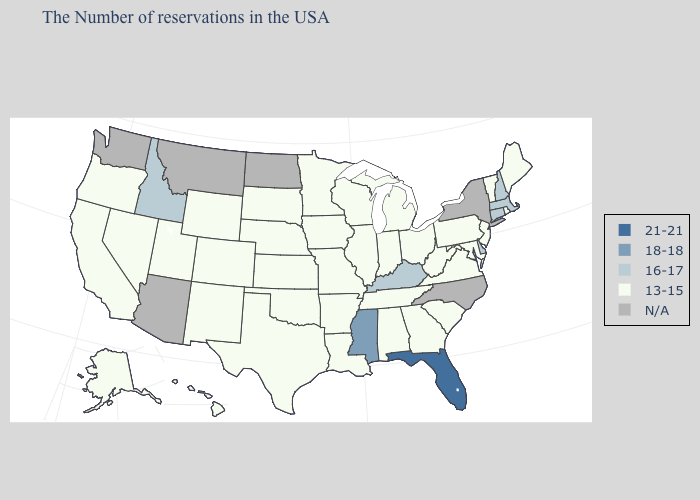Which states have the lowest value in the MidWest?
Write a very short answer. Ohio, Michigan, Indiana, Wisconsin, Illinois, Missouri, Minnesota, Iowa, Kansas, Nebraska, South Dakota. Which states have the lowest value in the USA?
Give a very brief answer. Maine, Rhode Island, Vermont, New Jersey, Maryland, Pennsylvania, Virginia, South Carolina, West Virginia, Ohio, Georgia, Michigan, Indiana, Alabama, Tennessee, Wisconsin, Illinois, Louisiana, Missouri, Arkansas, Minnesota, Iowa, Kansas, Nebraska, Oklahoma, Texas, South Dakota, Wyoming, Colorado, New Mexico, Utah, Nevada, California, Oregon, Alaska, Hawaii. Which states have the highest value in the USA?
Keep it brief. Florida. Among the states that border Missouri , does Iowa have the highest value?
Quick response, please. No. Name the states that have a value in the range N/A?
Concise answer only. New York, North Carolina, North Dakota, Montana, Arizona, Washington. Does the first symbol in the legend represent the smallest category?
Quick response, please. No. Does Massachusetts have the highest value in the Northeast?
Quick response, please. Yes. Does the map have missing data?
Keep it brief. Yes. Which states have the lowest value in the MidWest?
Give a very brief answer. Ohio, Michigan, Indiana, Wisconsin, Illinois, Missouri, Minnesota, Iowa, Kansas, Nebraska, South Dakota. How many symbols are there in the legend?
Be succinct. 5. What is the highest value in the Northeast ?
Be succinct. 16-17. Name the states that have a value in the range 13-15?
Write a very short answer. Maine, Rhode Island, Vermont, New Jersey, Maryland, Pennsylvania, Virginia, South Carolina, West Virginia, Ohio, Georgia, Michigan, Indiana, Alabama, Tennessee, Wisconsin, Illinois, Louisiana, Missouri, Arkansas, Minnesota, Iowa, Kansas, Nebraska, Oklahoma, Texas, South Dakota, Wyoming, Colorado, New Mexico, Utah, Nevada, California, Oregon, Alaska, Hawaii. Name the states that have a value in the range 21-21?
Concise answer only. Florida. Name the states that have a value in the range 18-18?
Concise answer only. Mississippi. Name the states that have a value in the range 13-15?
Give a very brief answer. Maine, Rhode Island, Vermont, New Jersey, Maryland, Pennsylvania, Virginia, South Carolina, West Virginia, Ohio, Georgia, Michigan, Indiana, Alabama, Tennessee, Wisconsin, Illinois, Louisiana, Missouri, Arkansas, Minnesota, Iowa, Kansas, Nebraska, Oklahoma, Texas, South Dakota, Wyoming, Colorado, New Mexico, Utah, Nevada, California, Oregon, Alaska, Hawaii. 